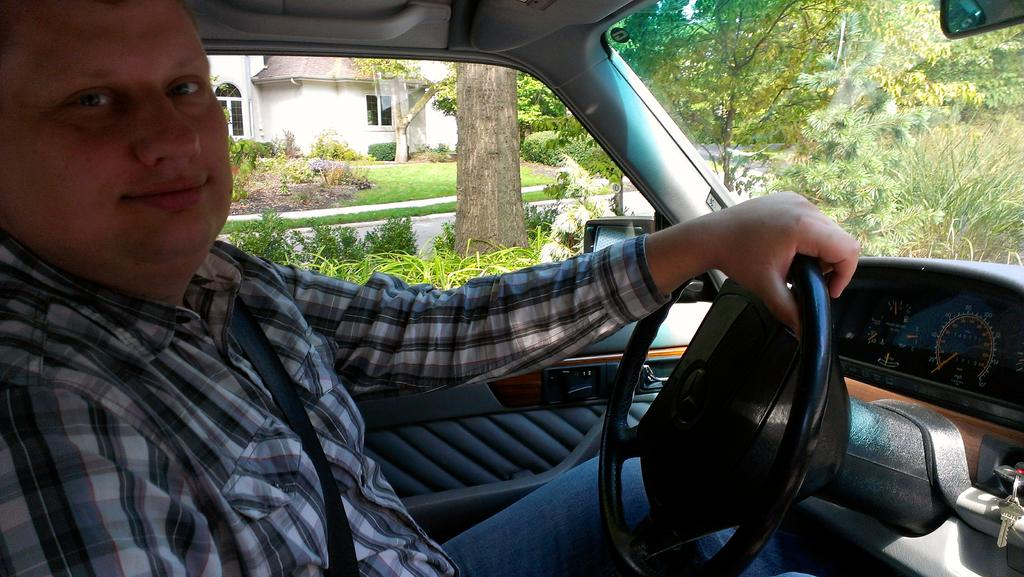What is the main subject of the image? There is a person in the image. What can be observed about the person's attire? The person is wearing clothes. Where is the person located in the image? The person is sitting inside a car. What is the person doing while sitting in the car? The person is holding a steering wheel with their hand. What type of natural scenery can be seen in the image? There are trees visible in the top right of the image. What type of beast can be seen pulling the car in the image? There is no beast present in the image; the person is sitting inside a car with a steering wheel. What type of rake is being used to clean the car in the image? There is no rake present in the image; the person is holding a steering wheel while sitting inside the car. 